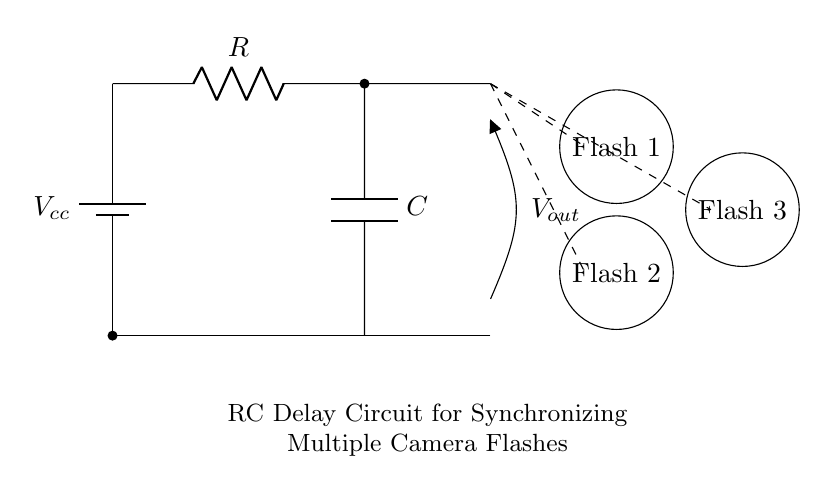What is the value of the capacitor in the circuit? The circuit diagram does not explicitly provide a numerical value for the capacitor. However, contextual knowledge of common capacitor values used in RC circuits could apply.
Answer: Not specified What type of circuit is depicted? The circuit shows an RC delay circuit, which combines a resistor and a capacitor to create a time delay for triggering. This is evident from the placement of the resistor and capacitor in series and their connection to the output.
Answer: RC delay circuit How many camera flashes are connected to this circuit? The diagram clearly shows three camera flash symbols that are connected to the output, indicating that there are three flashes in total.
Answer: Three What does the output voltage represent? The output voltage, denoted as Vout, signifies the voltage across the capacitor at the output terminal. This is where the signal for the camera flashes is taken from.
Answer: Vout What will happen when the capacitor charges completely? When the capacitor is fully charged, the output voltage stabilizes, and further flashes are synchronized based on the delay introduced by the resistor-capacitor timing. This allows for a synchronized discharge to trigger the connected camera flashes.
Answer: Synchronization occurs Which component controls the timing in this circuit? The timing in this circuit is controlled by the resistor and capacitor combination, specifically their values will determine the charge and discharge rates of the capacitor, thus affecting the delay for the flashes.
Answer: Resistor and capacitor 